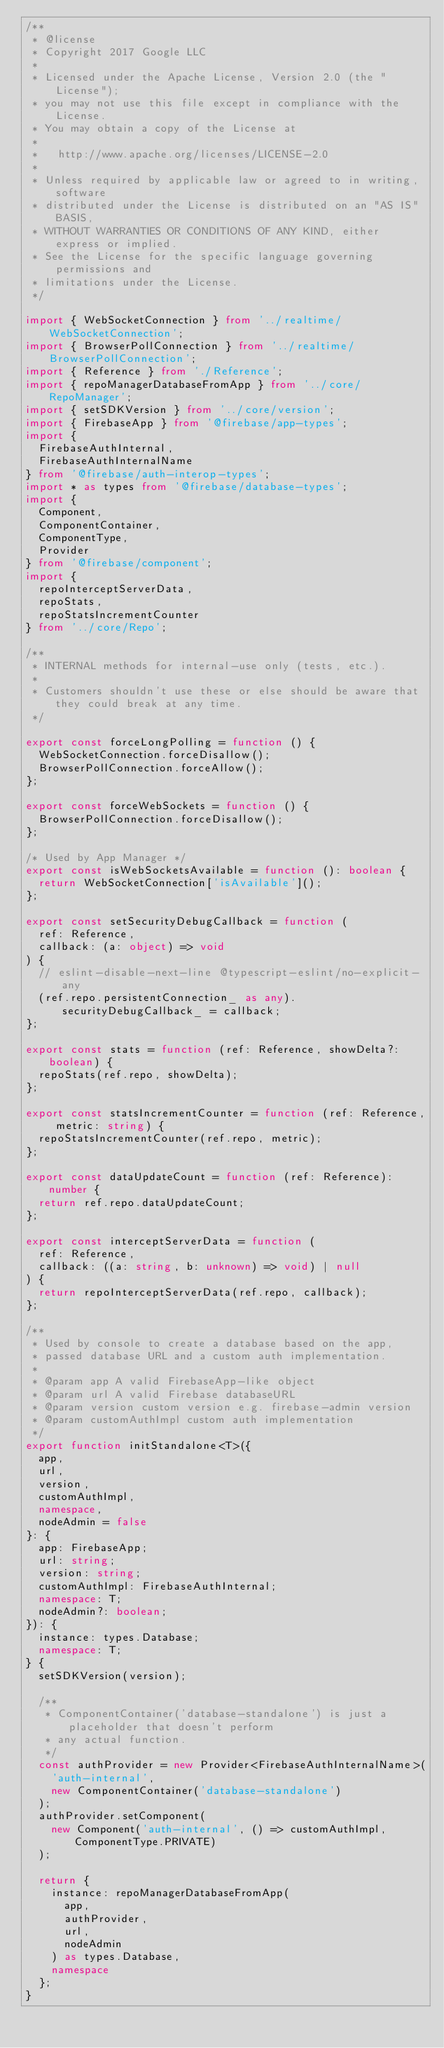Convert code to text. <code><loc_0><loc_0><loc_500><loc_500><_TypeScript_>/**
 * @license
 * Copyright 2017 Google LLC
 *
 * Licensed under the Apache License, Version 2.0 (the "License");
 * you may not use this file except in compliance with the License.
 * You may obtain a copy of the License at
 *
 *   http://www.apache.org/licenses/LICENSE-2.0
 *
 * Unless required by applicable law or agreed to in writing, software
 * distributed under the License is distributed on an "AS IS" BASIS,
 * WITHOUT WARRANTIES OR CONDITIONS OF ANY KIND, either express or implied.
 * See the License for the specific language governing permissions and
 * limitations under the License.
 */

import { WebSocketConnection } from '../realtime/WebSocketConnection';
import { BrowserPollConnection } from '../realtime/BrowserPollConnection';
import { Reference } from './Reference';
import { repoManagerDatabaseFromApp } from '../core/RepoManager';
import { setSDKVersion } from '../core/version';
import { FirebaseApp } from '@firebase/app-types';
import {
  FirebaseAuthInternal,
  FirebaseAuthInternalName
} from '@firebase/auth-interop-types';
import * as types from '@firebase/database-types';
import {
  Component,
  ComponentContainer,
  ComponentType,
  Provider
} from '@firebase/component';
import {
  repoInterceptServerData,
  repoStats,
  repoStatsIncrementCounter
} from '../core/Repo';

/**
 * INTERNAL methods for internal-use only (tests, etc.).
 *
 * Customers shouldn't use these or else should be aware that they could break at any time.
 */

export const forceLongPolling = function () {
  WebSocketConnection.forceDisallow();
  BrowserPollConnection.forceAllow();
};

export const forceWebSockets = function () {
  BrowserPollConnection.forceDisallow();
};

/* Used by App Manager */
export const isWebSocketsAvailable = function (): boolean {
  return WebSocketConnection['isAvailable']();
};

export const setSecurityDebugCallback = function (
  ref: Reference,
  callback: (a: object) => void
) {
  // eslint-disable-next-line @typescript-eslint/no-explicit-any
  (ref.repo.persistentConnection_ as any).securityDebugCallback_ = callback;
};

export const stats = function (ref: Reference, showDelta?: boolean) {
  repoStats(ref.repo, showDelta);
};

export const statsIncrementCounter = function (ref: Reference, metric: string) {
  repoStatsIncrementCounter(ref.repo, metric);
};

export const dataUpdateCount = function (ref: Reference): number {
  return ref.repo.dataUpdateCount;
};

export const interceptServerData = function (
  ref: Reference,
  callback: ((a: string, b: unknown) => void) | null
) {
  return repoInterceptServerData(ref.repo, callback);
};

/**
 * Used by console to create a database based on the app,
 * passed database URL and a custom auth implementation.
 *
 * @param app A valid FirebaseApp-like object
 * @param url A valid Firebase databaseURL
 * @param version custom version e.g. firebase-admin version
 * @param customAuthImpl custom auth implementation
 */
export function initStandalone<T>({
  app,
  url,
  version,
  customAuthImpl,
  namespace,
  nodeAdmin = false
}: {
  app: FirebaseApp;
  url: string;
  version: string;
  customAuthImpl: FirebaseAuthInternal;
  namespace: T;
  nodeAdmin?: boolean;
}): {
  instance: types.Database;
  namespace: T;
} {
  setSDKVersion(version);

  /**
   * ComponentContainer('database-standalone') is just a placeholder that doesn't perform
   * any actual function.
   */
  const authProvider = new Provider<FirebaseAuthInternalName>(
    'auth-internal',
    new ComponentContainer('database-standalone')
  );
  authProvider.setComponent(
    new Component('auth-internal', () => customAuthImpl, ComponentType.PRIVATE)
  );

  return {
    instance: repoManagerDatabaseFromApp(
      app,
      authProvider,
      url,
      nodeAdmin
    ) as types.Database,
    namespace
  };
}
</code> 